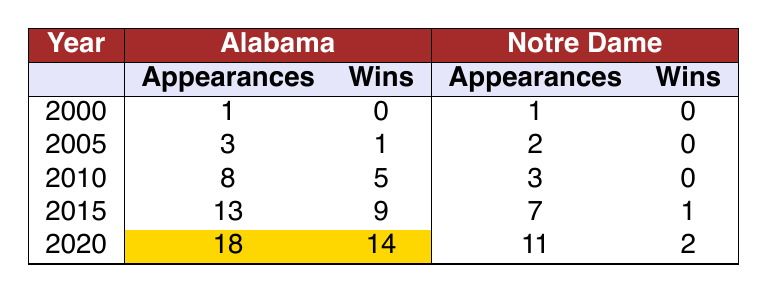What year did Alabama have the highest number of bowl appearances? Looking at the table, 2020 shows Alabama with the highest number of bowl appearances, which is 18.
Answer: 2020 How many bowl wins did Notre Dame have in the year 2015? In 2015, Notre Dame had 1 bowl win as indicated in the table.
Answer: 1 What is the total number of bowl appearances for Alabama from 2000 to 2020? To find the total, we sum the bowl appearances for each year: 1 + 3 + 8 + 13 + 18 = 43.
Answer: 43 Did Notre Dame ever have more bowl wins than Alabama in any year? In every year listed in the table, Alabama had equal or more bowl wins than Notre Dame; in 2015, Alabama had 9 wins while Notre Dame had only 1.
Answer: No What is the average number of bowl wins for Alabama over the years presented? Adding Alabama's bowl wins: 0 + 1 + 5 + 9 + 14 = 29. There are 5 years, so the average is 29 / 5 = 5.8.
Answer: 5.8 In which year did Alabama have the most bowl wins compared to their bowl appearances? In 2020, Alabama had 14 wins out of 18 appearances, which is approximately 77.8% efficiency, the highest.
Answer: 2020 What are the differences in bowl wins between Alabama and Notre Dame in 2020? In 2020, Alabama had 14 bowl wins, and Notre Dame had 2 bowl wins, so the difference is 14 - 2 = 12.
Answer: 12 How many combined bowl wins did both Alabama and Notre Dame achieve in 2010? Alabama had 5 wins and Notre Dame had 0 wins in 2010, so the combined total is 5 + 0 = 5.
Answer: 5 What year did both teams have the same number of bowl wins? In 2000, both Alabama and Notre Dame had 0 bowl wins, making it the year they matched.
Answer: 2000 